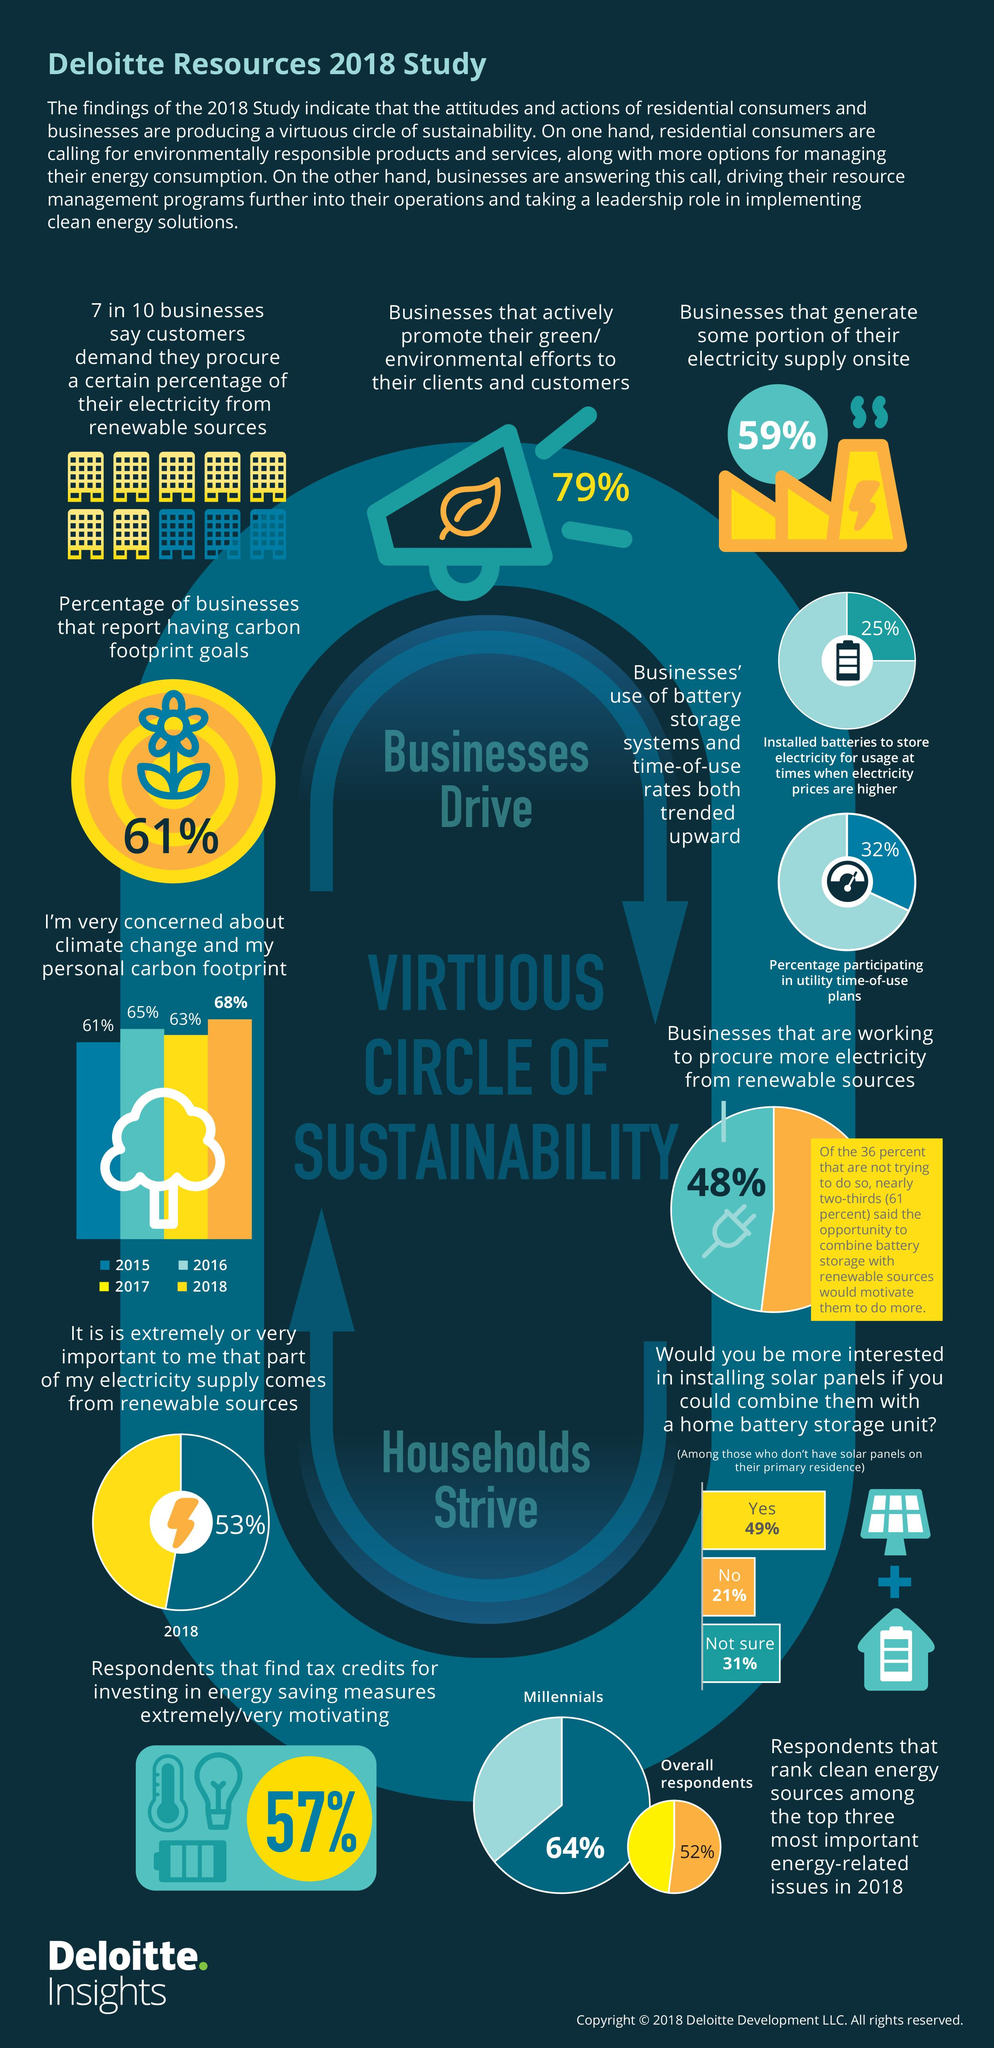Identify some key points in this picture. According to the Deloitte Resources 2018 study, 57% of respondents found that tax credits for investing in energy-saving measures to be extremely motivating. According to the Deloitte Resources 2018 study, 61% of businesses reported having carbon footprint goals. According to the Deloitte Resources 2018 study, 65% of respondents expressed concern about climate change and their carbon footprint in 2016. According to the Deloitte Resources 2018 study, 79% of businesses actively promote their environmental efforts to their clients and customers. According to the Deloitte Resources 2018 study, 59% of businesses generate some portion of their electricity supply onsite. 